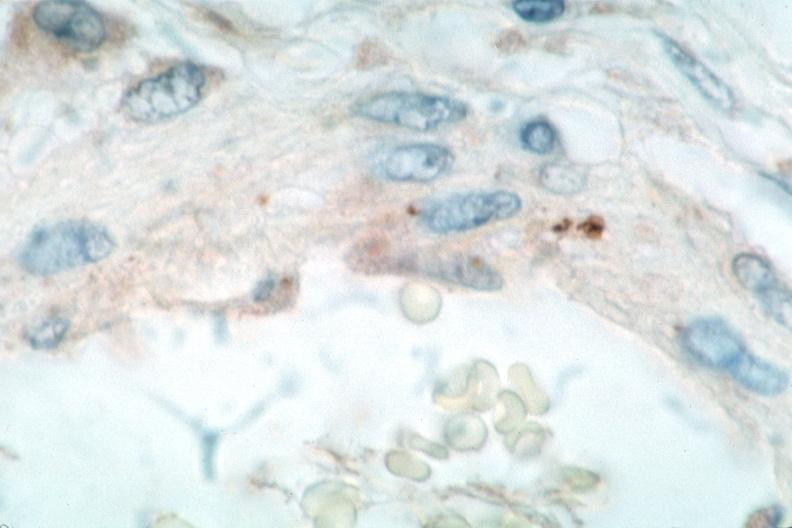what is present?
Answer the question using a single word or phrase. Cardiovascular 